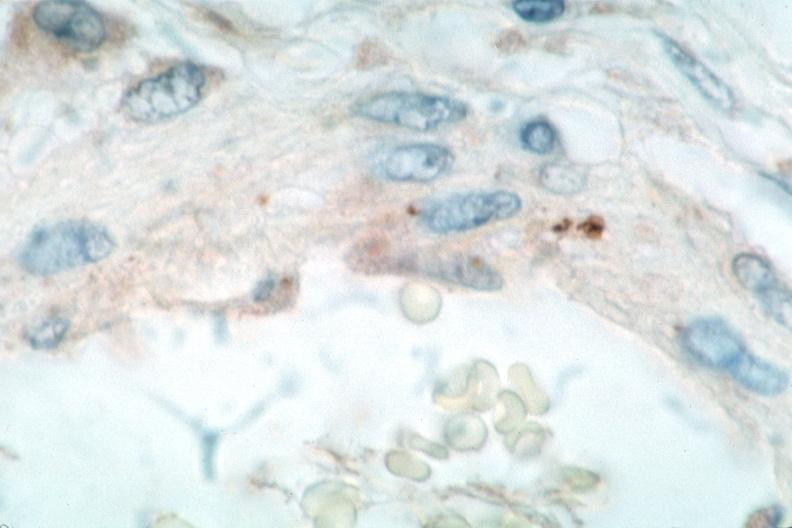what is present?
Answer the question using a single word or phrase. Cardiovascular 